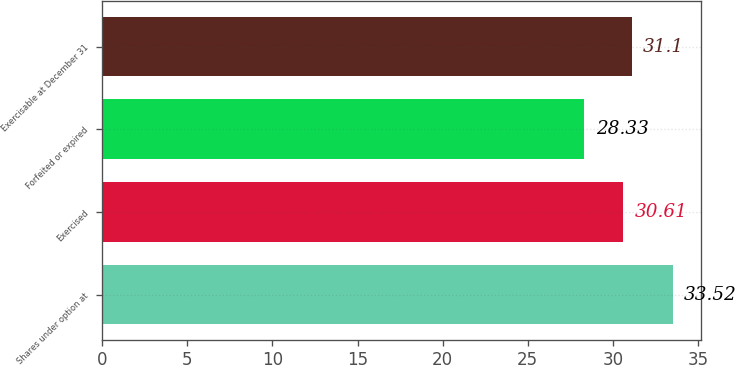Convert chart. <chart><loc_0><loc_0><loc_500><loc_500><bar_chart><fcel>Shares under option at<fcel>Exercised<fcel>Forfeited or expired<fcel>Exercisable at December 31<nl><fcel>33.52<fcel>30.61<fcel>28.33<fcel>31.1<nl></chart> 